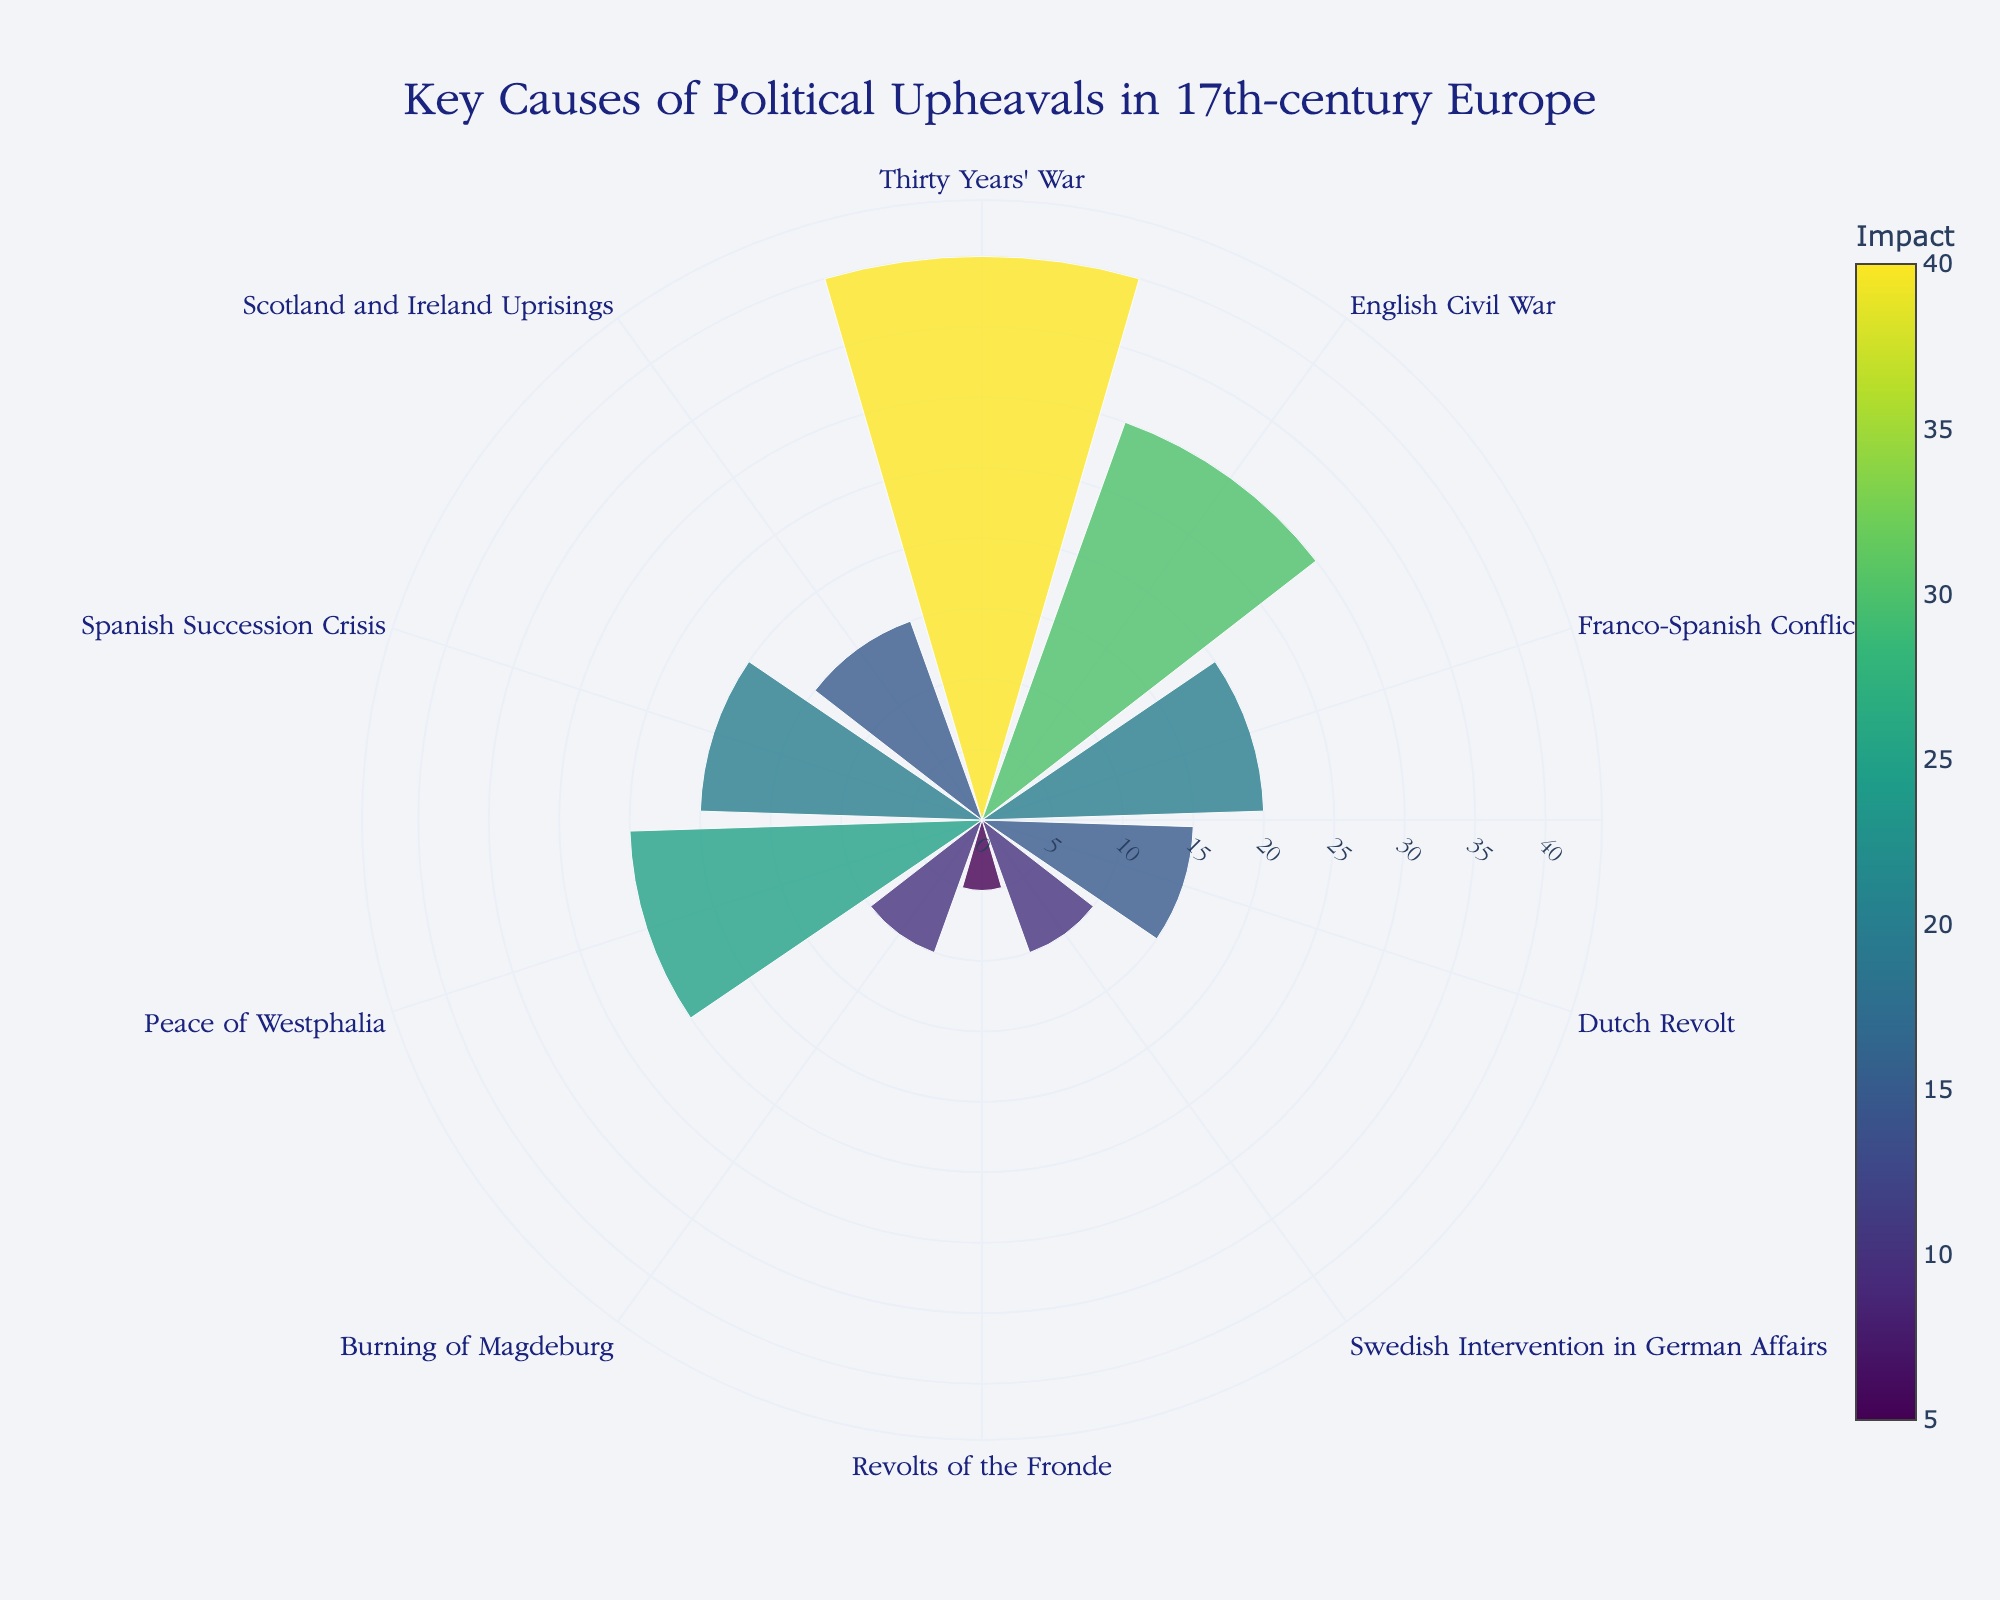Which cause of political upheaval is represented with the highest impact? The highest impact, represented by the longest bar, is for the Thirty Years' War. By looking at the length of the bars and the color intensity, the Thirty Years' War has the maximum value of 40.
Answer: Thirty Years' War Which conflicts have an equal impact of 20? By examining the bars of equal lengths and color shades, the Franco-Spanish Conflict and the Spanish Succession Crisis both have an impact value of 20.
Answer: Franco-Spanish Conflict, Spanish Succession Crisis What is the total combined impact of the Revolts of the Fronde and the Peace of Westphalia? The Revolts of the Fronde has an impact of 5, and the Peace of Westphalia has an impact of 25. Summing these values gives 5 + 25 = 30.
Answer: 30 Which event has a higher impact, the Dutch Revolt or the Swedish Intervention in German Affairs? By comparing the lengths and colors of the bars, the Dutch Revolt has an impact of 15, whereas the Swedish Intervention in German Affairs has an impact of 10. Therefore, the Dutch Revolt has a higher impact.
Answer: Dutch Revolt How many events have an impact value greater than 15? To find this, count the number of bars extending beyond the 15-mark. The events are the Thirty Years' War (40), English Civil War (30), and Peace of Westphalia (25), totaling three events.
Answer: 3 What is the average impact of the English Civil War, Swedish Intervention in German Affairs, and the Burning of Magdeburg? The impacts are: English Civil War (30), Swedish Intervention in German Affairs (10), and Burning of Magdeburg (10). The sum is 30 + 10 + 10 = 50. Dividing by 3, the average is 50/3 ≈ 16.67.
Answer: 16.67 Which cause of political upheaval is closest in impact to the Peace of Westphalia? By comparing the bars, the Franco-Spanish Conflict (20) and Peace of Westphalia (25) have the most similar impact values, with a difference of 5.
Answer: Franco-Spanish Conflict What is the combined contribution of the two least impactful events? The two events with the shortest bars, or the least impacts, are the Revolts of the Fronde (5) and the Swedish Intervention in German Affairs (10). Summing these gives 5 + 10 = 15.
Answer: 15 